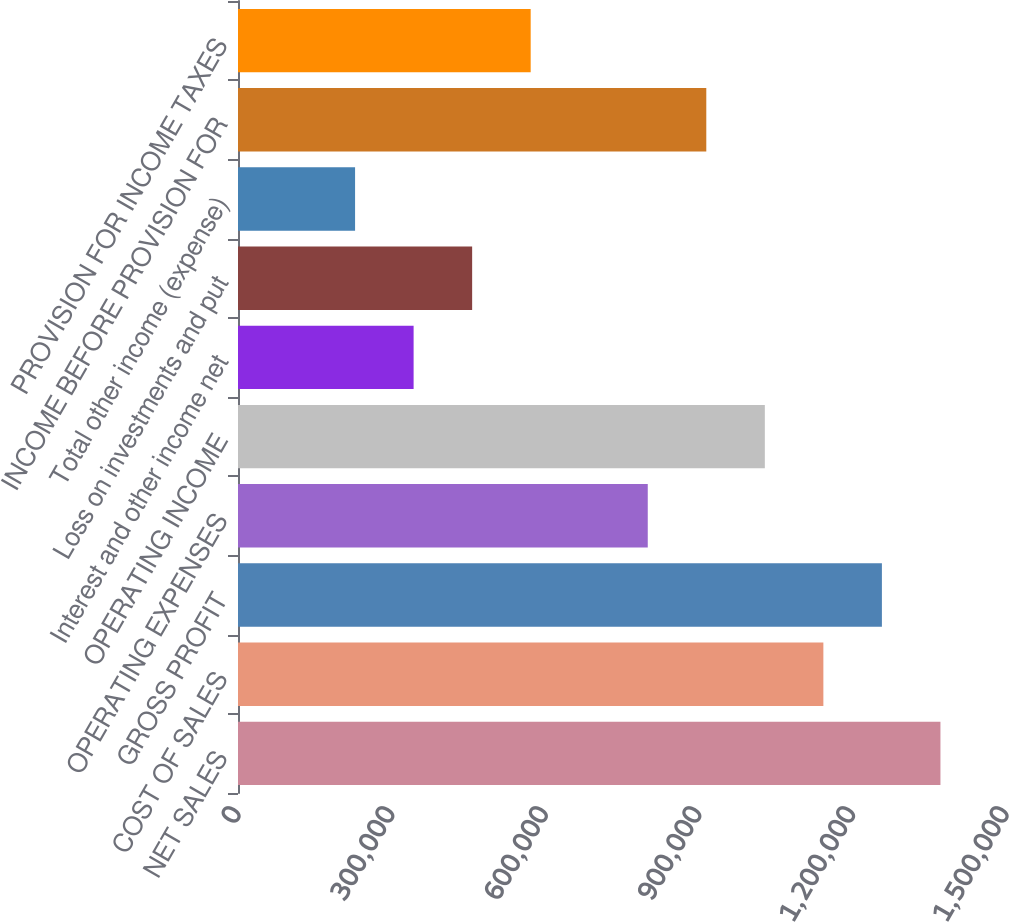Convert chart. <chart><loc_0><loc_0><loc_500><loc_500><bar_chart><fcel>NET SALES<fcel>COST OF SALES<fcel>GROSS PROFIT<fcel>OPERATING EXPENSES<fcel>OPERATING INCOME<fcel>Interest and other income net<fcel>Loss on investments and put<fcel>Total other income (expense)<fcel>INCOME BEFORE PROVISION FOR<fcel>PROVISION FOR INCOME TAXES<nl><fcel>1.37196e+06<fcel>1.1433e+06<fcel>1.25763e+06<fcel>800310<fcel>1.02897e+06<fcel>342991<fcel>457321<fcel>228662<fcel>914640<fcel>571651<nl></chart> 